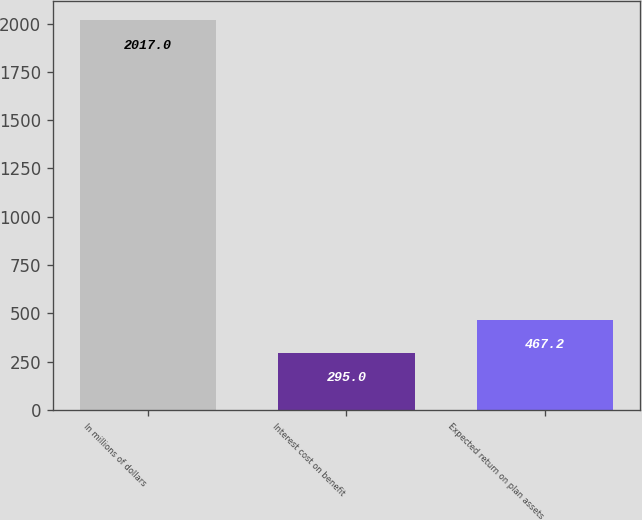Convert chart to OTSL. <chart><loc_0><loc_0><loc_500><loc_500><bar_chart><fcel>In millions of dollars<fcel>Interest cost on benefit<fcel>Expected return on plan assets<nl><fcel>2017<fcel>295<fcel>467.2<nl></chart> 